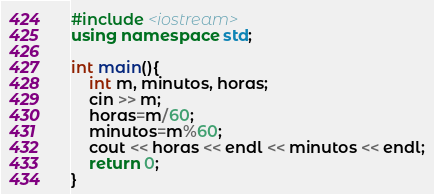<code> <loc_0><loc_0><loc_500><loc_500><_C++_>#include <iostream>
using namespace std;

int main(){
	int m, minutos, horas;
	cin >> m;
	horas=m/60;
	minutos=m%60;
	cout << horas << endl << minutos << endl;
	return 0;
}
</code> 